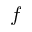<formula> <loc_0><loc_0><loc_500><loc_500>f</formula> 